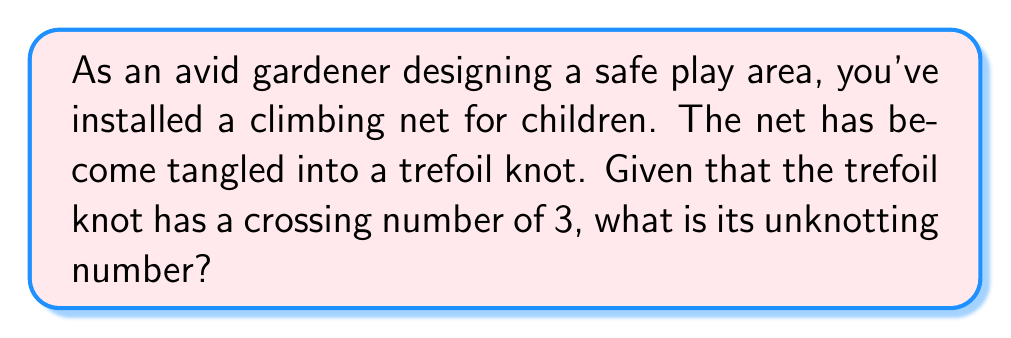What is the answer to this math problem? To solve this problem, we need to understand a few key concepts:

1. The trefoil knot is one of the simplest non-trivial knots.
2. The crossing number of a knot is the minimum number of crossings in any diagram of the knot.
3. The unknotting number of a knot is the minimum number of times the knot must be passed through itself to untangle it.

For the trefoil knot:

1. We know it has a crossing number of 3.
2. To determine the unknotting number, we need to consider how many crossing changes are required to transform it into an unknot.

[asy]
import geometry;

path p = (0,0)..(1,1)..(2,0)..(1,-1)..cycle;
draw(p, linewidth(2));
draw((0.9,0.1)--(1.1,-0.1), linewidth(2));
draw((1.9,0.1)--(2.1,-0.1), linewidth(2));
draw((0.1,-0.1)--(0.3,0.1), linewidth(2));
[/asy]

3. For the trefoil knot, changing any one of the three crossings will result in the unknot.

4. Therefore, the unknotting number of the trefoil knot is 1.

It's worth noting that for many knots, the unknotting number is less than or equal to the floor of half the crossing number:

$$ u(K) \leq \lfloor \frac{c(K)}{2} \rfloor $$

Where $u(K)$ is the unknotting number and $c(K)$ is the crossing number.

In this case, $\lfloor \frac{3}{2} \rfloor = 1$, which aligns with our result.
Answer: 1 